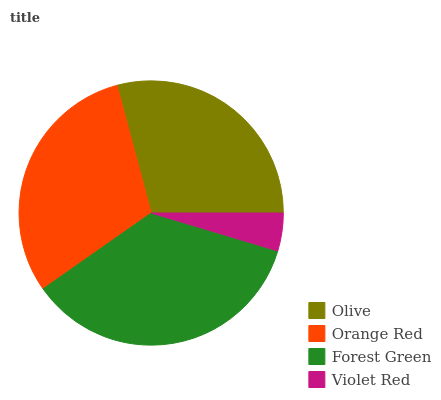Is Violet Red the minimum?
Answer yes or no. Yes. Is Forest Green the maximum?
Answer yes or no. Yes. Is Orange Red the minimum?
Answer yes or no. No. Is Orange Red the maximum?
Answer yes or no. No. Is Orange Red greater than Olive?
Answer yes or no. Yes. Is Olive less than Orange Red?
Answer yes or no. Yes. Is Olive greater than Orange Red?
Answer yes or no. No. Is Orange Red less than Olive?
Answer yes or no. No. Is Orange Red the high median?
Answer yes or no. Yes. Is Olive the low median?
Answer yes or no. Yes. Is Olive the high median?
Answer yes or no. No. Is Orange Red the low median?
Answer yes or no. No. 